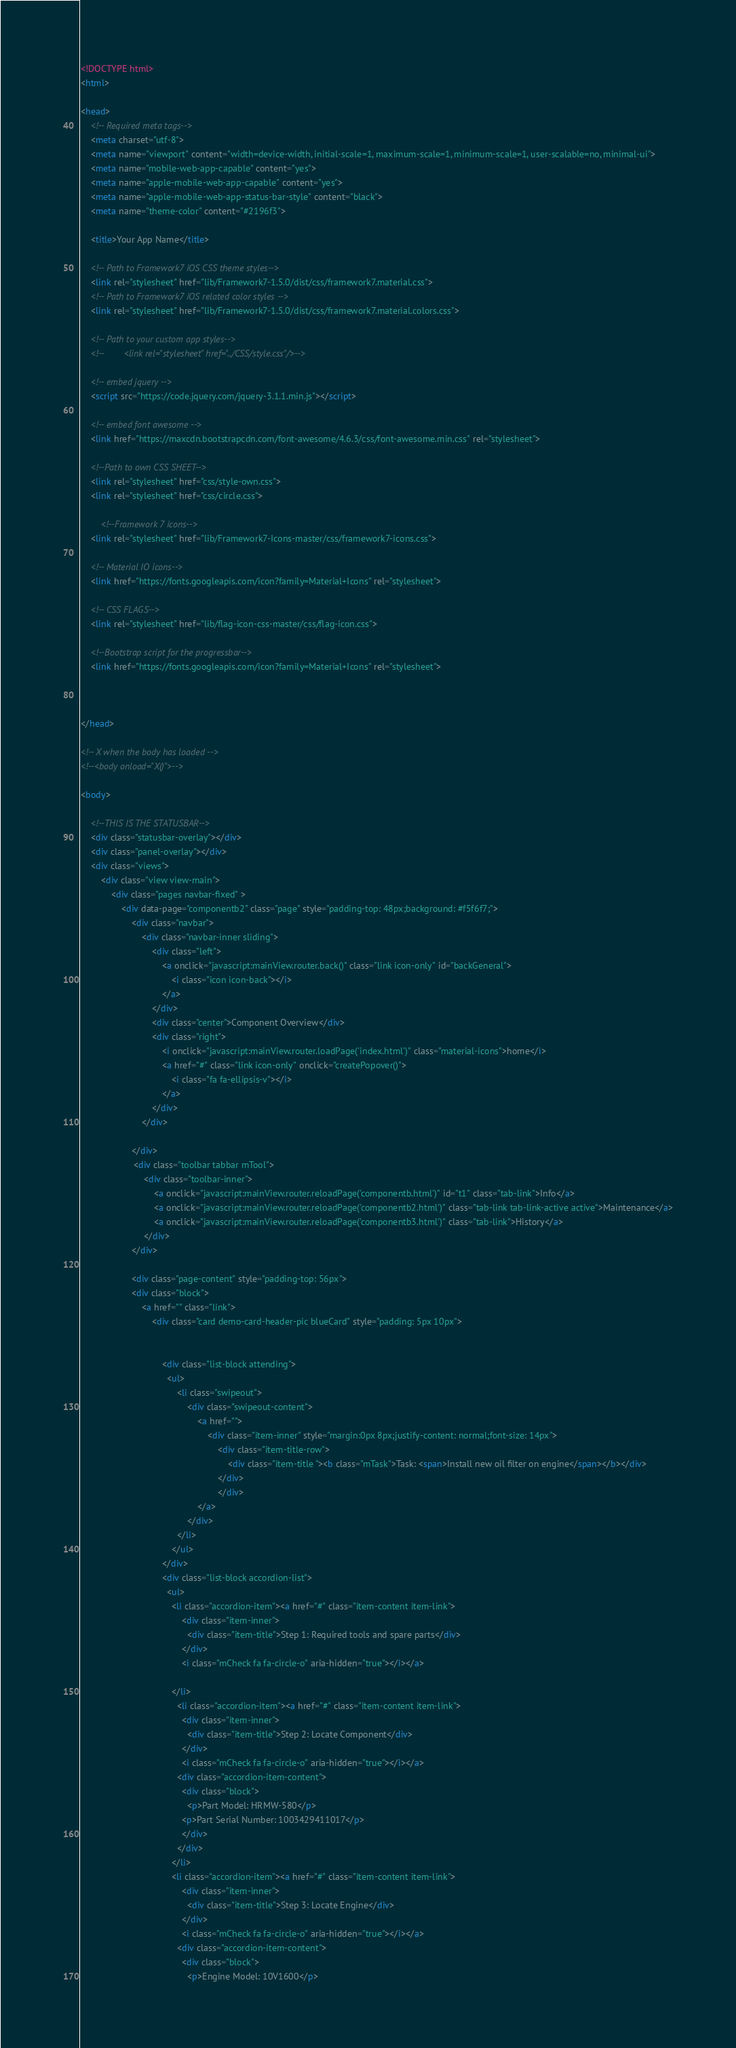Convert code to text. <code><loc_0><loc_0><loc_500><loc_500><_HTML_><!DOCTYPE html>
<html>

<head>
    <!-- Required meta tags-->
    <meta charset="utf-8">
    <meta name="viewport" content="width=device-width, initial-scale=1, maximum-scale=1, minimum-scale=1, user-scalable=no, minimal-ui">
    <meta name="mobile-web-app-capable" content="yes">
    <meta name="apple-mobile-web-app-capable" content="yes">
    <meta name="apple-mobile-web-app-status-bar-style" content="black">
    <meta name="theme-color" content="#2196f3">

    <title>Your App Name</title>

    <!-- Path to Framework7 iOS CSS theme styles-->
    <link rel="stylesheet" href="lib/Framework7-1.5.0/dist/css/framework7.material.css">
    <!-- Path to Framework7 iOS related color styles -->
    <link rel="stylesheet" href="lib/Framework7-1.5.0/dist/css/framework7.material.colors.css">

    <!-- Path to your custom app styles-->
    <!--        <link rel="stylesheet" href="../CSS/style.css"/>-->

    <!-- embed jquery -->
    <script src="https://code.jquery.com/jquery-3.1.1.min.js"></script>

    <!-- embed font awesome -->
    <link href="https://maxcdn.bootstrapcdn.com/font-awesome/4.6.3/css/font-awesome.min.css" rel="stylesheet">

    <!--Path to own CSS SHEET-->
    <link rel="stylesheet" href="css/style-own.css">
    <link rel="stylesheet" href="css/circle.css">
    
        <!--Framework 7 icons-->
    <link rel="stylesheet" href="lib/Framework7-Icons-master/css/framework7-icons.css">
    
    <!-- Material IO icons-->
    <link href="https://fonts.googleapis.com/icon?family=Material+Icons" rel="stylesheet">
            
    <!-- CSS FLAGS-->
    <link rel="stylesheet" href="lib/flag-icon-css-master/css/flag-icon.css">
    
    <!--Bootstrap script for the progressbar-->
    <link href="https://fonts.googleapis.com/icon?family=Material+Icons" rel="stylesheet">

    

</head>

<!-- X when the body has loaded -->
<!--<body onload="X()">-->

<body>

    <!--THIS IS THE STATUSBAR-->
    <div class="statusbar-overlay"></div>
    <div class="panel-overlay"></div>
    <div class="views">
        <div class="view view-main">
            <div class="pages navbar-fixed" >
                <div data-page="componentb2" class="page" style="padding-top: 48px;background: #f5f6f7;">
                    <div class="navbar">
                        <div class="navbar-inner sliding">
                            <div class="left">
                                <a onclick="javascript:mainView.router.back()" class="link icon-only" id="backGeneral">
                                    <i class="icon icon-back"></i>
                                </a>
                            </div>
                            <div class="center">Component Overview</div>
                            <div class="right">
                                <i onclick="javascript:mainView.router.loadPage('index.html')" class="material-icons">home</i>
                                <a href="#" class="link icon-only" onclick="createPopover()">
                                    <i class="fa fa-ellipsis-v"></i>
                                </a>
                            </div>
                        </div>
                        
                    </div>
                     <div class="toolbar tabbar mTool">
                         <div class="toolbar-inner">
                             <a onclick="javascript:mainView.router.reloadPage('componentb.html')" id="t1" class="tab-link">Info</a>
                             <a onclick="javascript:mainView.router.reloadPage('componentb2.html')" class="tab-link tab-link-active active">Maintenance</a>
                             <a onclick="javascript:mainView.router.reloadPage('componentb3.html')" class="tab-link">History</a>
                         </div>
                    </div>
                    
                    <div class="page-content" style="padding-top: 56px">
                    <div class="block">
                        <a href="" class="link">
                            <div class="card demo-card-header-pic blueCard" style="padding: 5px 10px">
                                
                            
                                <div class="list-block attending">
                                  <ul>
                                      <li class="swipeout">
                                          <div class="swipeout-content">
                                              <a href="">
                                                  <div class="item-inner" style="margin:0px 8px;justify-content: normal;font-size: 14px">
                                                      <div class="item-title-row">
                                                          <div class="item-title "><b class="mTask">Task: <span>Install new oil filter on engine</span></b></div>
                                                      </div>
                                                      </div>
                                              </a>
                                          </div>                                     
                                      </li>
                                    </ul>                                      
                                </div>
                                <div class="list-block accordion-list">
                                  <ul>
                                    <li class="accordion-item"><a href="#" class="item-content item-link">
                                        <div class="item-inner">
                                          <div class="item-title">Step 1: Required tools and spare parts</div>
                                        </div>
                                        <i class="mCheck fa fa-circle-o" aria-hidden="true"></i></a>
                                      
                                    </li>
                                      <li class="accordion-item"><a href="#" class="item-content item-link">
                                        <div class="item-inner">
                                          <div class="item-title">Step 2: Locate Component</div>
                                        </div>
                                        <i class="mCheck fa fa-circle-o" aria-hidden="true"></i></a>
                                      <div class="accordion-item-content">
                                        <div class="block">
                                          <p>Part Model: HRMW-580</p>
                                        <p>Part Serial Number: 1003429411017</p>
                                        </div>
                                      </div>
                                    </li>
                                    <li class="accordion-item"><a href="#" class="item-content item-link">
                                        <div class="item-inner">
                                          <div class="item-title">Step 3: Locate Engine</div>
                                        </div>
                                        <i class="mCheck fa fa-circle-o" aria-hidden="true"></i></a>
                                      <div class="accordion-item-content">
                                        <div class="block">
                                          <p>Engine Model: 10V1600</p></code> 